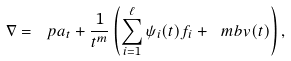<formula> <loc_0><loc_0><loc_500><loc_500>\nabla = \ p a _ { t } + \frac { 1 } { t ^ { m } } \left ( \sum _ { i = 1 } ^ { \ell } \psi _ { i } ( t ) f _ { i } + { \ m b v } ( t ) \right ) ,</formula> 